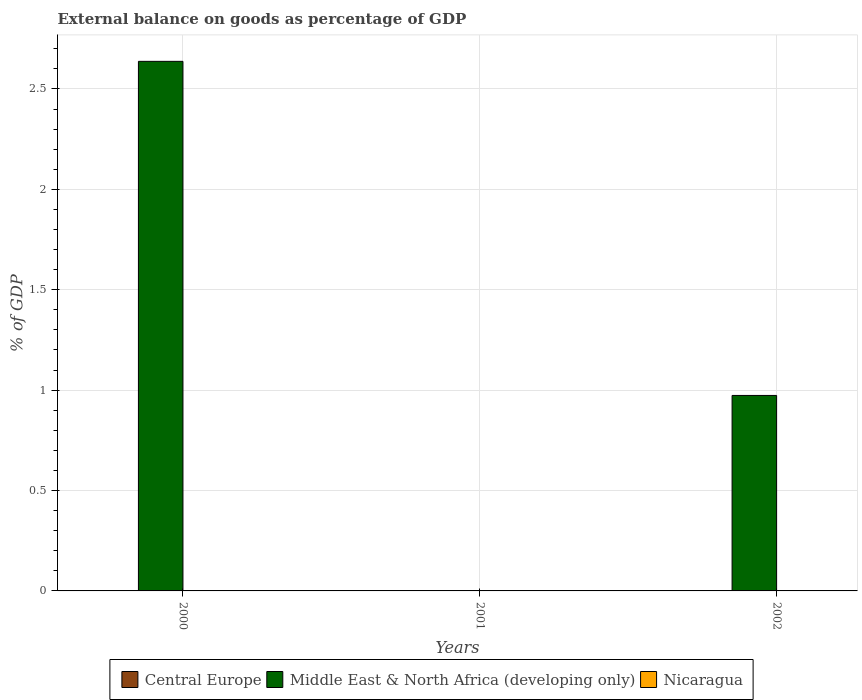How many different coloured bars are there?
Provide a short and direct response. 1. How many bars are there on the 2nd tick from the left?
Offer a very short reply. 0. How many bars are there on the 3rd tick from the right?
Offer a terse response. 1. Across all years, what is the maximum external balance on goods as percentage of GDP in Middle East & North Africa (developing only)?
Your answer should be compact. 2.64. Across all years, what is the minimum external balance on goods as percentage of GDP in Middle East & North Africa (developing only)?
Provide a short and direct response. 0. What is the total external balance on goods as percentage of GDP in Nicaragua in the graph?
Make the answer very short. 0. What is the difference between the external balance on goods as percentage of GDP in Middle East & North Africa (developing only) in 2000 and that in 2002?
Ensure brevity in your answer.  1.66. What is the average external balance on goods as percentage of GDP in Middle East & North Africa (developing only) per year?
Your answer should be very brief. 1.2. What is the difference between the highest and the lowest external balance on goods as percentage of GDP in Middle East & North Africa (developing only)?
Make the answer very short. 2.64. In how many years, is the external balance on goods as percentage of GDP in Central Europe greater than the average external balance on goods as percentage of GDP in Central Europe taken over all years?
Provide a short and direct response. 0. How many bars are there?
Offer a very short reply. 2. Does the graph contain any zero values?
Make the answer very short. Yes. Does the graph contain grids?
Make the answer very short. Yes. Where does the legend appear in the graph?
Give a very brief answer. Bottom center. How are the legend labels stacked?
Your answer should be very brief. Horizontal. What is the title of the graph?
Your response must be concise. External balance on goods as percentage of GDP. Does "Mozambique" appear as one of the legend labels in the graph?
Provide a succinct answer. No. What is the label or title of the Y-axis?
Provide a succinct answer. % of GDP. What is the % of GDP of Middle East & North Africa (developing only) in 2000?
Keep it short and to the point. 2.64. What is the % of GDP in Nicaragua in 2001?
Offer a terse response. 0. What is the % of GDP of Central Europe in 2002?
Offer a terse response. 0. What is the % of GDP of Middle East & North Africa (developing only) in 2002?
Keep it short and to the point. 0.97. What is the % of GDP of Nicaragua in 2002?
Ensure brevity in your answer.  0. Across all years, what is the maximum % of GDP of Middle East & North Africa (developing only)?
Your answer should be very brief. 2.64. Across all years, what is the minimum % of GDP in Middle East & North Africa (developing only)?
Your answer should be very brief. 0. What is the total % of GDP in Middle East & North Africa (developing only) in the graph?
Offer a very short reply. 3.61. What is the total % of GDP of Nicaragua in the graph?
Offer a very short reply. 0. What is the difference between the % of GDP in Middle East & North Africa (developing only) in 2000 and that in 2002?
Provide a short and direct response. 1.66. What is the average % of GDP of Central Europe per year?
Offer a terse response. 0. What is the average % of GDP in Middle East & North Africa (developing only) per year?
Ensure brevity in your answer.  1.2. What is the ratio of the % of GDP in Middle East & North Africa (developing only) in 2000 to that in 2002?
Offer a terse response. 2.71. What is the difference between the highest and the lowest % of GDP in Middle East & North Africa (developing only)?
Your answer should be compact. 2.64. 